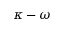<formula> <loc_0><loc_0><loc_500><loc_500>\kappa - \omega</formula> 